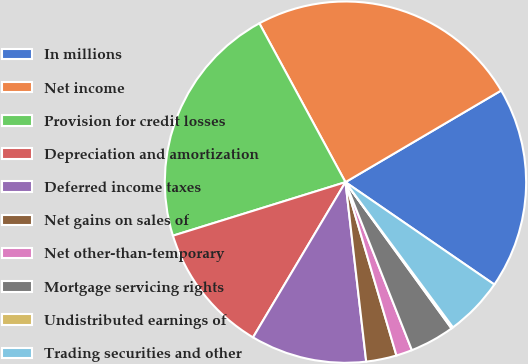<chart> <loc_0><loc_0><loc_500><loc_500><pie_chart><fcel>In millions<fcel>Net income<fcel>Provision for credit losses<fcel>Depreciation and amortization<fcel>Deferred income taxes<fcel>Net gains on sales of<fcel>Net other-than-temporary<fcel>Mortgage servicing rights<fcel>Undistributed earnings of<fcel>Trading securities and other<nl><fcel>18.05%<fcel>24.44%<fcel>21.88%<fcel>11.66%<fcel>10.38%<fcel>2.72%<fcel>1.44%<fcel>3.99%<fcel>0.16%<fcel>5.27%<nl></chart> 